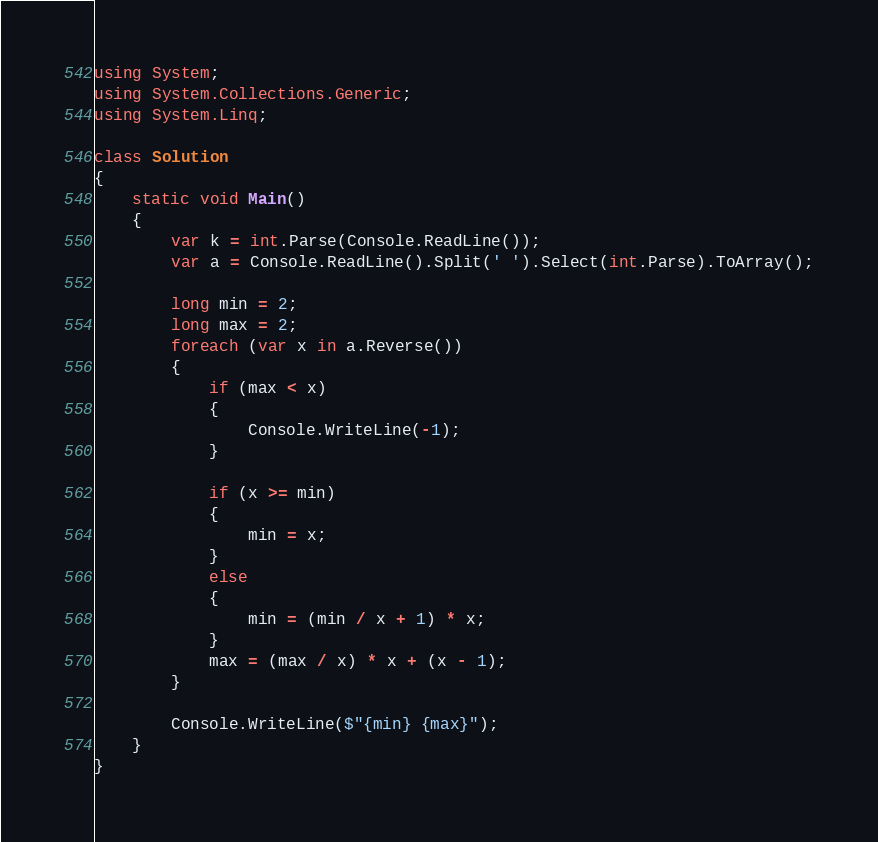Convert code to text. <code><loc_0><loc_0><loc_500><loc_500><_C#_>using System;
using System.Collections.Generic;
using System.Linq;

class Solution
{
    static void Main()
    {
        var k = int.Parse(Console.ReadLine());
        var a = Console.ReadLine().Split(' ').Select(int.Parse).ToArray();

        long min = 2;
        long max = 2;
        foreach (var x in a.Reverse())
        {
            if (max < x)
            {
                Console.WriteLine(-1);
            }

            if (x >= min)
            {
                min = x;
            }
            else
            {
                min = (min / x + 1) * x;
            }
            max = (max / x) * x + (x - 1);
        }

        Console.WriteLine($"{min} {max}");
    }
}</code> 